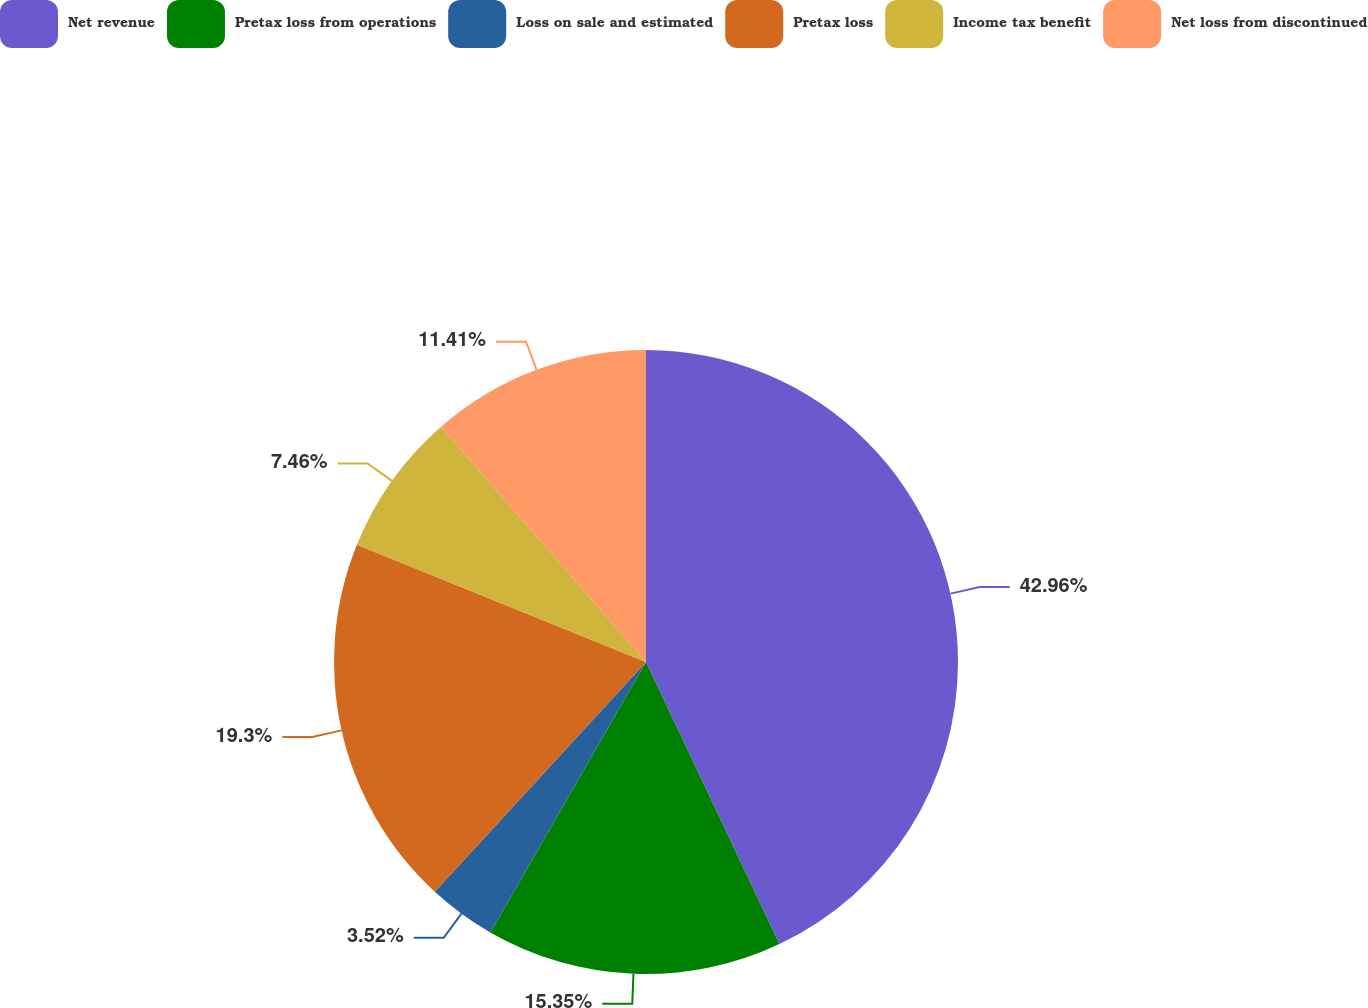<chart> <loc_0><loc_0><loc_500><loc_500><pie_chart><fcel>Net revenue<fcel>Pretax loss from operations<fcel>Loss on sale and estimated<fcel>Pretax loss<fcel>Income tax benefit<fcel>Net loss from discontinued<nl><fcel>42.97%<fcel>15.35%<fcel>3.52%<fcel>19.3%<fcel>7.46%<fcel>11.41%<nl></chart> 